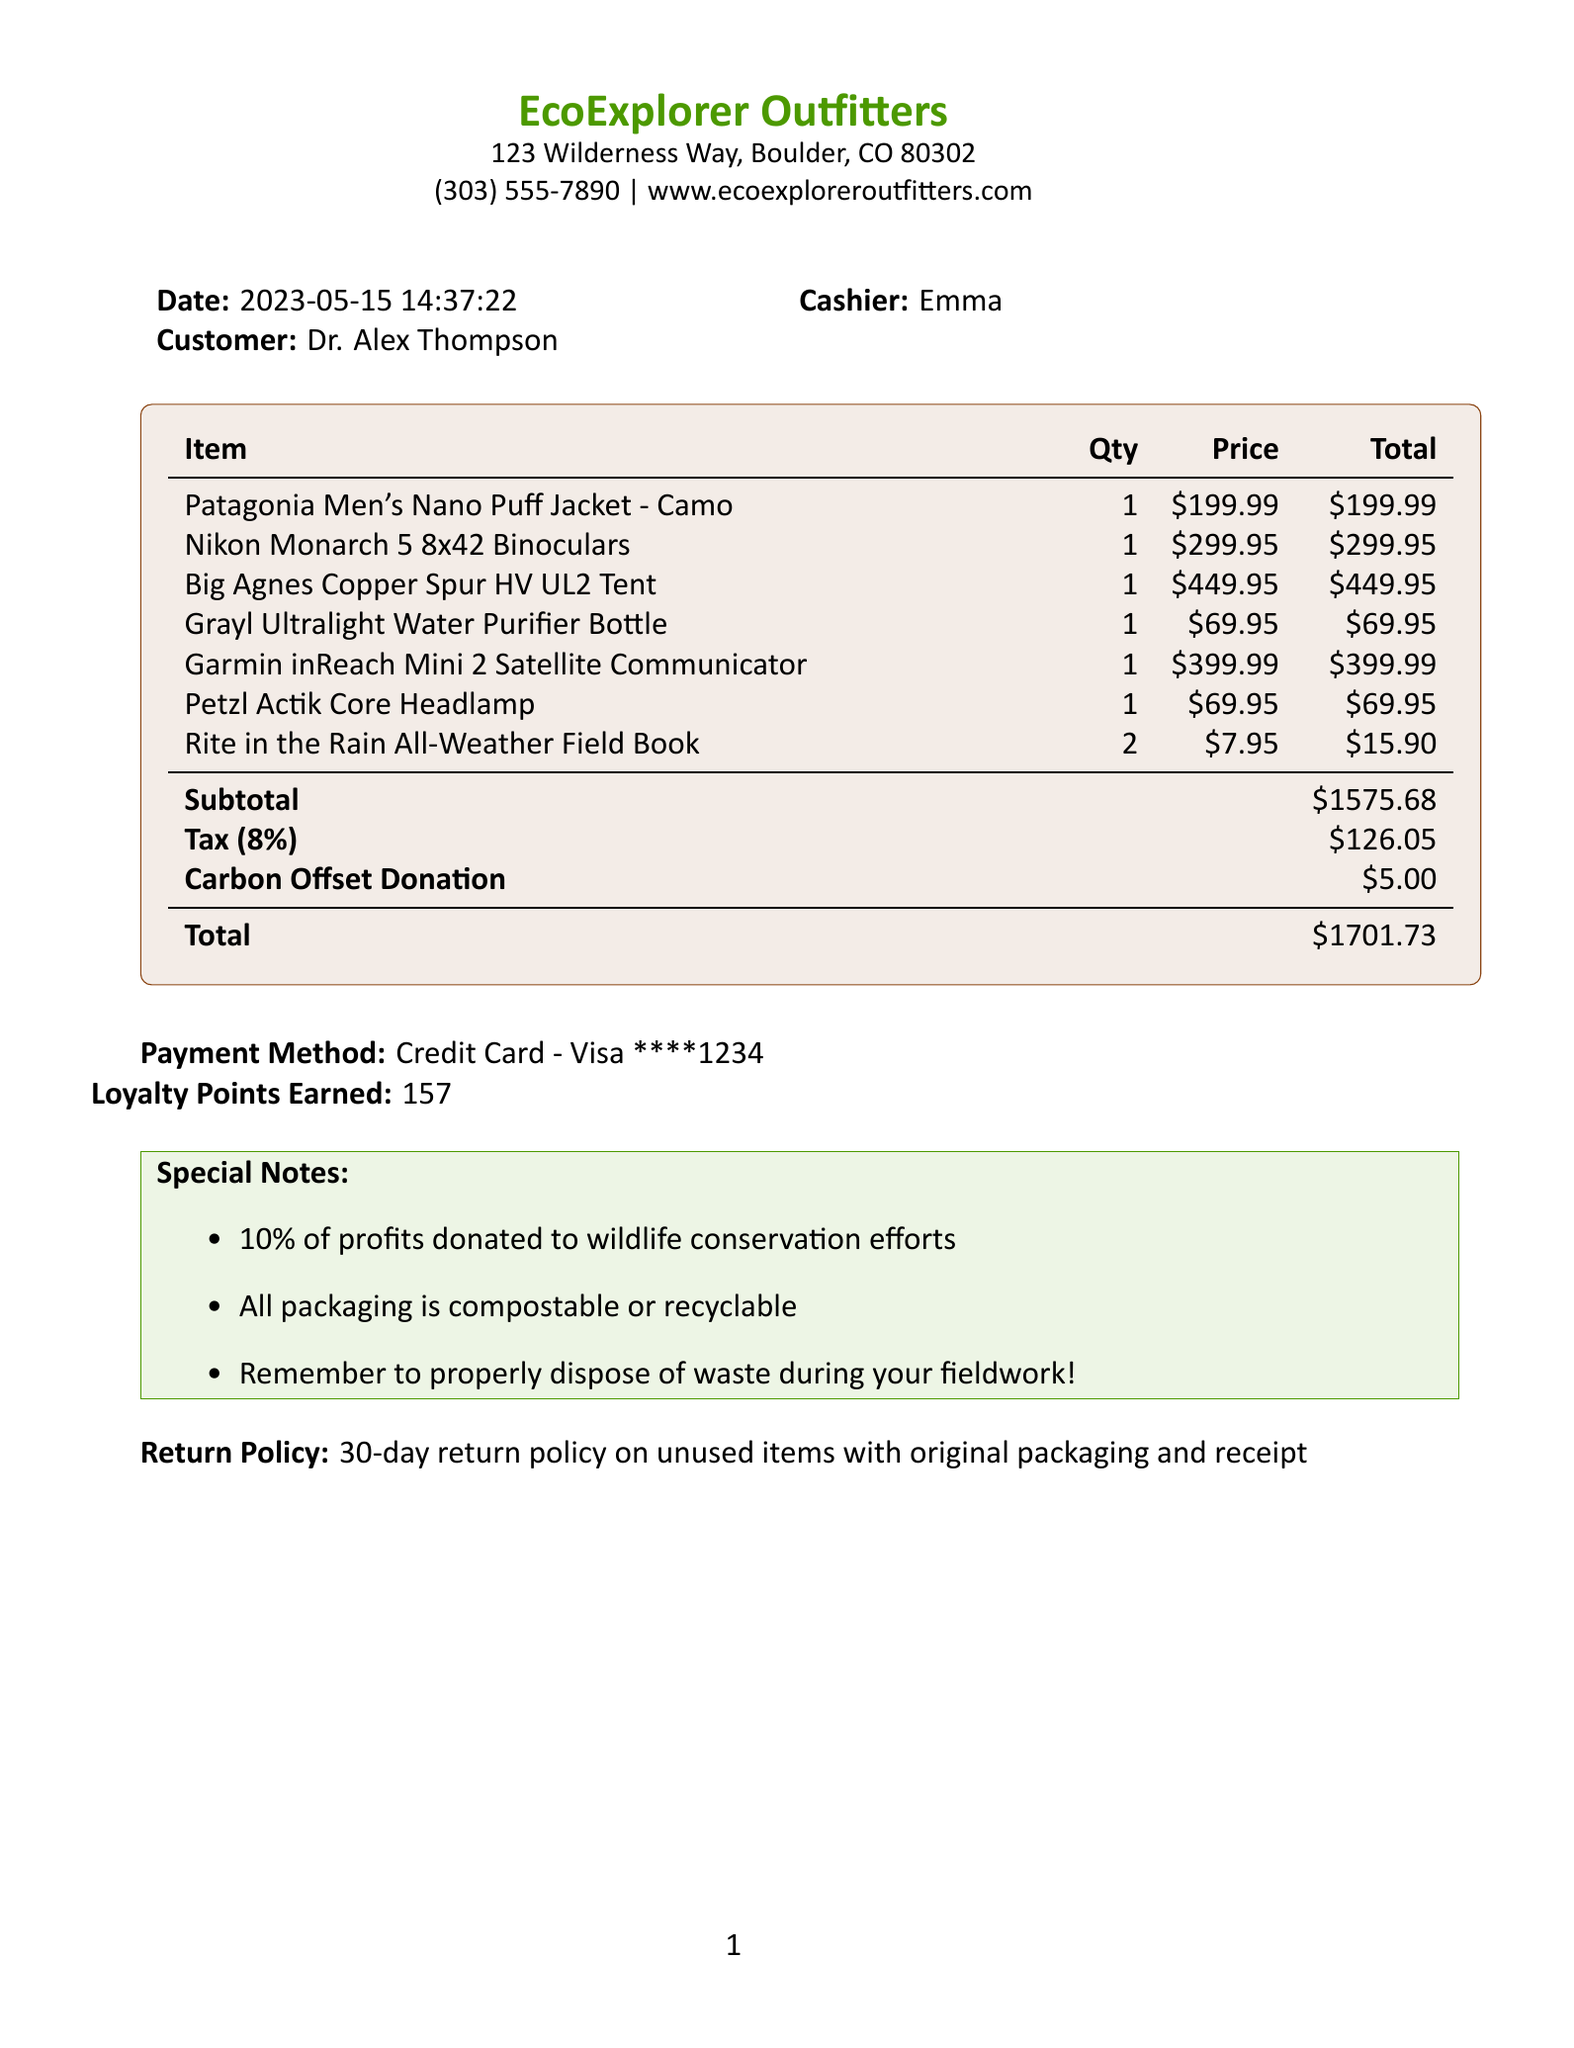What is the name of the store? The store's name is prominently displayed at the top of the receipt.
Answer: EcoExplorer Outfitters What did Dr. Alex Thompson buy? The items purchased by the customer are listed in detail.
Answer: Camouflage clothing, binoculars, sustainable camping equipment What is the total amount spent? The total amount is calculated after adding the subtotal and tax.
Answer: 1701.73 How many loyalty points were earned? The total earned points are indicated in the document.
Answer: 157 What is the date of the purchase? The date is summarized at the top of the receipt.
Answer: 2023-05-15 Who was the cashier? The name of the cashier is mentioned in the transaction details.
Answer: Emma What is the return policy? The return policy is specified in the document for clarity.
Answer: 30-day return policy on unused items with original packaging and receipt How much was donated for carbon offset? The amount dedicated to carbon offset donation is clearly stated.
Answer: 5.00 What type of payment was used? The payment method is detailed at the end of the receipt.
Answer: Credit Card - Visa ****1234 